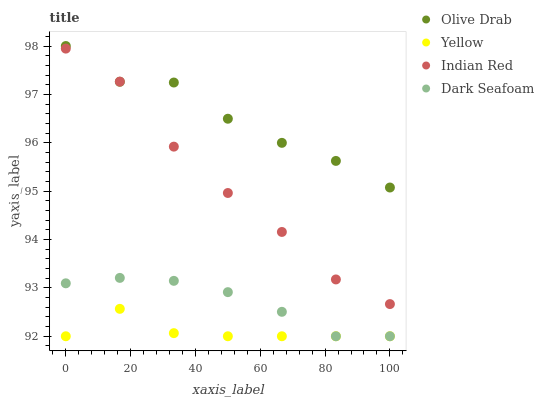Does Yellow have the minimum area under the curve?
Answer yes or no. Yes. Does Olive Drab have the maximum area under the curve?
Answer yes or no. Yes. Does Dark Seafoam have the minimum area under the curve?
Answer yes or no. No. Does Dark Seafoam have the maximum area under the curve?
Answer yes or no. No. Is Dark Seafoam the smoothest?
Answer yes or no. Yes. Is Olive Drab the roughest?
Answer yes or no. Yes. Is Yellow the smoothest?
Answer yes or no. No. Is Yellow the roughest?
Answer yes or no. No. Does Dark Seafoam have the lowest value?
Answer yes or no. Yes. Does Olive Drab have the lowest value?
Answer yes or no. No. Does Olive Drab have the highest value?
Answer yes or no. Yes. Does Dark Seafoam have the highest value?
Answer yes or no. No. Is Dark Seafoam less than Olive Drab?
Answer yes or no. Yes. Is Olive Drab greater than Yellow?
Answer yes or no. Yes. Does Olive Drab intersect Indian Red?
Answer yes or no. Yes. Is Olive Drab less than Indian Red?
Answer yes or no. No. Is Olive Drab greater than Indian Red?
Answer yes or no. No. Does Dark Seafoam intersect Olive Drab?
Answer yes or no. No. 